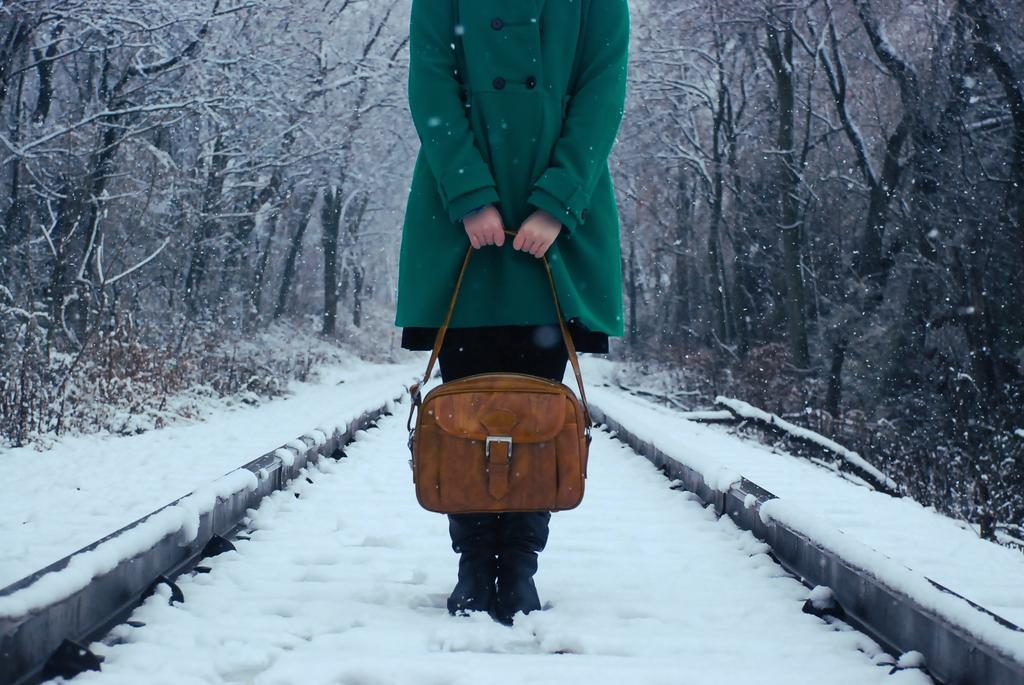Who is present in the image? There is a lady in the image. What is the lady holding in the image? The lady is holding a bag. What is the lady standing on in the image? The lady is standing on the floor. What is the condition of the floor in the image? There is snow on the floor. What can be seen in the background of the image? There are trees with snow around the lady. How does the lady measure the distance between the trees in the image? There is no indication in the image that the lady is measuring anything, nor is there any visible tool for measuring. 